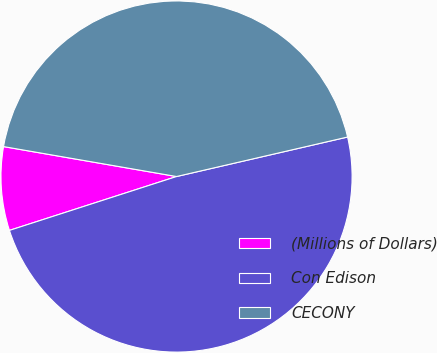Convert chart. <chart><loc_0><loc_0><loc_500><loc_500><pie_chart><fcel>(Millions of Dollars)<fcel>Con Edison<fcel>CECONY<nl><fcel>7.69%<fcel>48.65%<fcel>43.66%<nl></chart> 